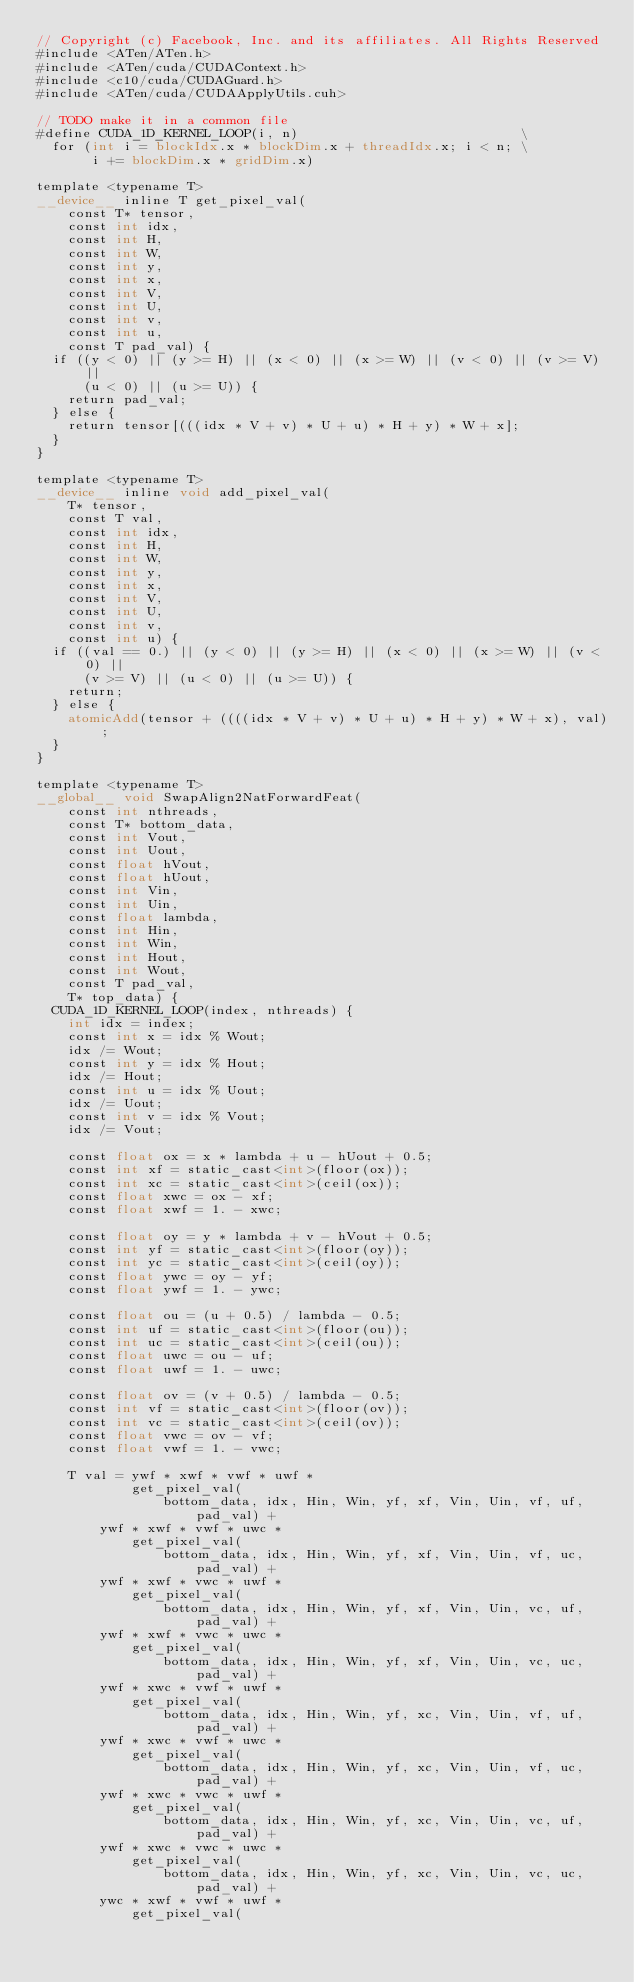Convert code to text. <code><loc_0><loc_0><loc_500><loc_500><_Cuda_>// Copyright (c) Facebook, Inc. and its affiliates. All Rights Reserved
#include <ATen/ATen.h>
#include <ATen/cuda/CUDAContext.h>
#include <c10/cuda/CUDAGuard.h>
#include <ATen/cuda/CUDAApplyUtils.cuh>

// TODO make it in a common file
#define CUDA_1D_KERNEL_LOOP(i, n)                            \
  for (int i = blockIdx.x * blockDim.x + threadIdx.x; i < n; \
       i += blockDim.x * gridDim.x)

template <typename T>
__device__ inline T get_pixel_val(
    const T* tensor,
    const int idx,
    const int H,
    const int W,
    const int y,
    const int x,
    const int V,
    const int U,
    const int v,
    const int u,
    const T pad_val) {
  if ((y < 0) || (y >= H) || (x < 0) || (x >= W) || (v < 0) || (v >= V) ||
      (u < 0) || (u >= U)) {
    return pad_val;
  } else {
    return tensor[(((idx * V + v) * U + u) * H + y) * W + x];
  }
}

template <typename T>
__device__ inline void add_pixel_val(
    T* tensor,
    const T val,
    const int idx,
    const int H,
    const int W,
    const int y,
    const int x,
    const int V,
    const int U,
    const int v,
    const int u) {
  if ((val == 0.) || (y < 0) || (y >= H) || (x < 0) || (x >= W) || (v < 0) ||
      (v >= V) || (u < 0) || (u >= U)) {
    return;
  } else {
    atomicAdd(tensor + ((((idx * V + v) * U + u) * H + y) * W + x), val);
  }
}

template <typename T>
__global__ void SwapAlign2NatForwardFeat(
    const int nthreads,
    const T* bottom_data,
    const int Vout,
    const int Uout,
    const float hVout,
    const float hUout,
    const int Vin,
    const int Uin,
    const float lambda,
    const int Hin,
    const int Win,
    const int Hout,
    const int Wout,
    const T pad_val,
    T* top_data) {
  CUDA_1D_KERNEL_LOOP(index, nthreads) {
    int idx = index;
    const int x = idx % Wout;
    idx /= Wout;
    const int y = idx % Hout;
    idx /= Hout;
    const int u = idx % Uout;
    idx /= Uout;
    const int v = idx % Vout;
    idx /= Vout;

    const float ox = x * lambda + u - hUout + 0.5;
    const int xf = static_cast<int>(floor(ox));
    const int xc = static_cast<int>(ceil(ox));
    const float xwc = ox - xf;
    const float xwf = 1. - xwc;

    const float oy = y * lambda + v - hVout + 0.5;
    const int yf = static_cast<int>(floor(oy));
    const int yc = static_cast<int>(ceil(oy));
    const float ywc = oy - yf;
    const float ywf = 1. - ywc;

    const float ou = (u + 0.5) / lambda - 0.5;
    const int uf = static_cast<int>(floor(ou));
    const int uc = static_cast<int>(ceil(ou));
    const float uwc = ou - uf;
    const float uwf = 1. - uwc;

    const float ov = (v + 0.5) / lambda - 0.5;
    const int vf = static_cast<int>(floor(ov));
    const int vc = static_cast<int>(ceil(ov));
    const float vwc = ov - vf;
    const float vwf = 1. - vwc;

    T val = ywf * xwf * vwf * uwf *
            get_pixel_val(
                bottom_data, idx, Hin, Win, yf, xf, Vin, Uin, vf, uf, pad_val) +
        ywf * xwf * vwf * uwc *
            get_pixel_val(
                bottom_data, idx, Hin, Win, yf, xf, Vin, Uin, vf, uc, pad_val) +
        ywf * xwf * vwc * uwf *
            get_pixel_val(
                bottom_data, idx, Hin, Win, yf, xf, Vin, Uin, vc, uf, pad_val) +
        ywf * xwf * vwc * uwc *
            get_pixel_val(
                bottom_data, idx, Hin, Win, yf, xf, Vin, Uin, vc, uc, pad_val) +
        ywf * xwc * vwf * uwf *
            get_pixel_val(
                bottom_data, idx, Hin, Win, yf, xc, Vin, Uin, vf, uf, pad_val) +
        ywf * xwc * vwf * uwc *
            get_pixel_val(
                bottom_data, idx, Hin, Win, yf, xc, Vin, Uin, vf, uc, pad_val) +
        ywf * xwc * vwc * uwf *
            get_pixel_val(
                bottom_data, idx, Hin, Win, yf, xc, Vin, Uin, vc, uf, pad_val) +
        ywf * xwc * vwc * uwc *
            get_pixel_val(
                bottom_data, idx, Hin, Win, yf, xc, Vin, Uin, vc, uc, pad_val) +
        ywc * xwf * vwf * uwf *
            get_pixel_val(</code> 